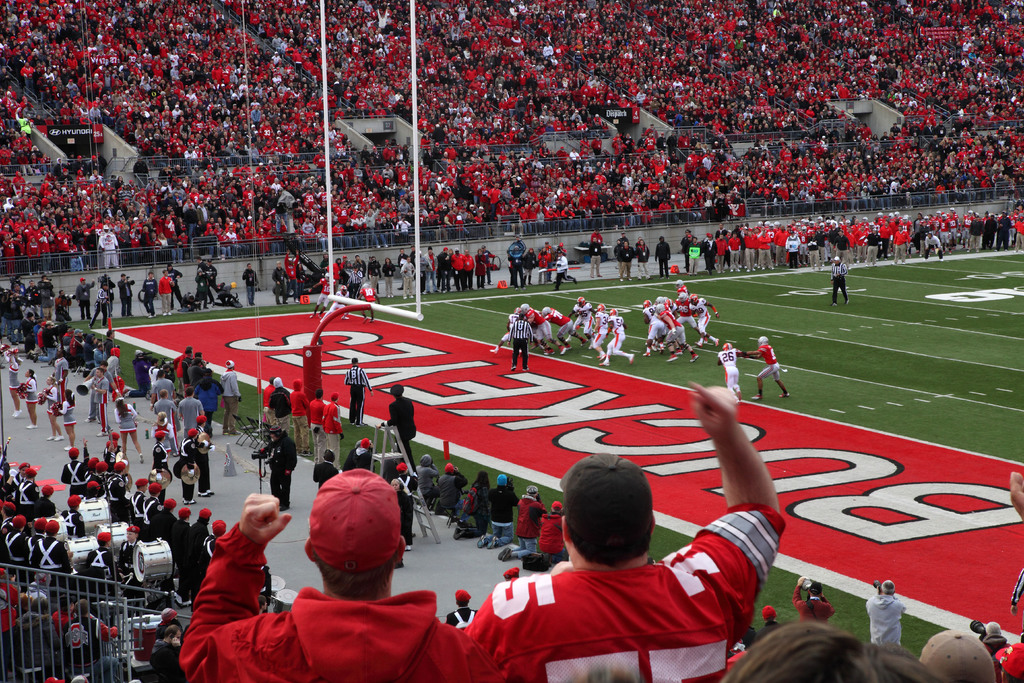Can you describe the main features of this image for me?
 The image captures a thrilling moment at a football game held at Ohio State University's stadium. From the perspective of the stands, we can see the field alive with action, players in mid-play, and a crowd that's a sea of red and white - the home team's colors. The field itself is a testament to the home team's spirit, marked with their logo and end zones painted in a vibrant red. The crowd is in full cheer, their excitement palpable as the home team takes the offense. It's a snapshot of the exhilarating atmosphere that comes with a live game at the stadium. 